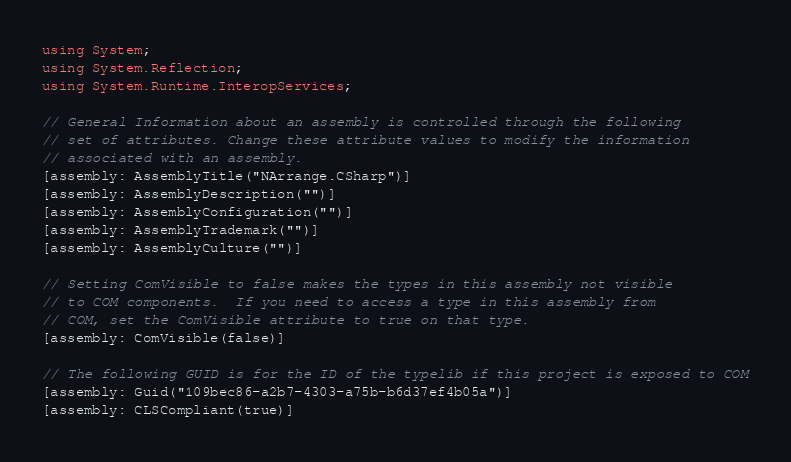<code> <loc_0><loc_0><loc_500><loc_500><_C#_>using System;
using System.Reflection;
using System.Runtime.InteropServices;

// General Information about an assembly is controlled through the following
// set of attributes. Change these attribute values to modify the information
// associated with an assembly.
[assembly: AssemblyTitle("NArrange.CSharp")]
[assembly: AssemblyDescription("")]
[assembly: AssemblyConfiguration("")]
[assembly: AssemblyTrademark("")]
[assembly: AssemblyCulture("")]

// Setting ComVisible to false makes the types in this assembly not visible
// to COM components.  If you need to access a type in this assembly from
// COM, set the ComVisible attribute to true on that type.
[assembly: ComVisible(false)]

// The following GUID is for the ID of the typelib if this project is exposed to COM
[assembly: Guid("109bec86-a2b7-4303-a75b-b6d37ef4b05a")]
[assembly: CLSCompliant(true)]</code> 